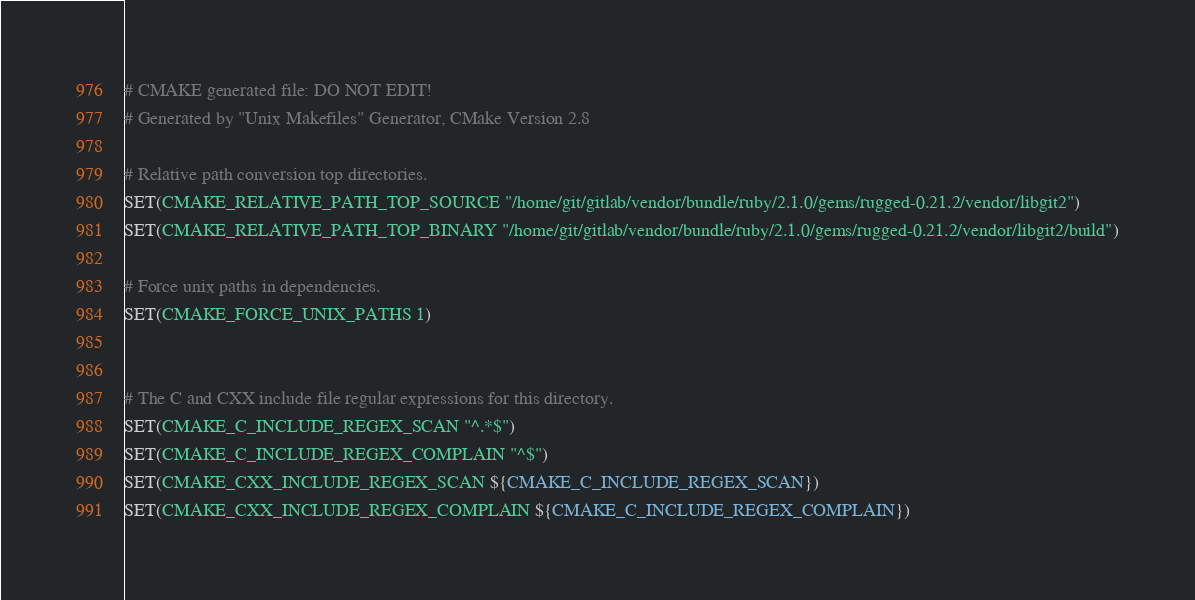Convert code to text. <code><loc_0><loc_0><loc_500><loc_500><_CMake_># CMAKE generated file: DO NOT EDIT!
# Generated by "Unix Makefiles" Generator, CMake Version 2.8

# Relative path conversion top directories.
SET(CMAKE_RELATIVE_PATH_TOP_SOURCE "/home/git/gitlab/vendor/bundle/ruby/2.1.0/gems/rugged-0.21.2/vendor/libgit2")
SET(CMAKE_RELATIVE_PATH_TOP_BINARY "/home/git/gitlab/vendor/bundle/ruby/2.1.0/gems/rugged-0.21.2/vendor/libgit2/build")

# Force unix paths in dependencies.
SET(CMAKE_FORCE_UNIX_PATHS 1)


# The C and CXX include file regular expressions for this directory.
SET(CMAKE_C_INCLUDE_REGEX_SCAN "^.*$")
SET(CMAKE_C_INCLUDE_REGEX_COMPLAIN "^$")
SET(CMAKE_CXX_INCLUDE_REGEX_SCAN ${CMAKE_C_INCLUDE_REGEX_SCAN})
SET(CMAKE_CXX_INCLUDE_REGEX_COMPLAIN ${CMAKE_C_INCLUDE_REGEX_COMPLAIN})
</code> 